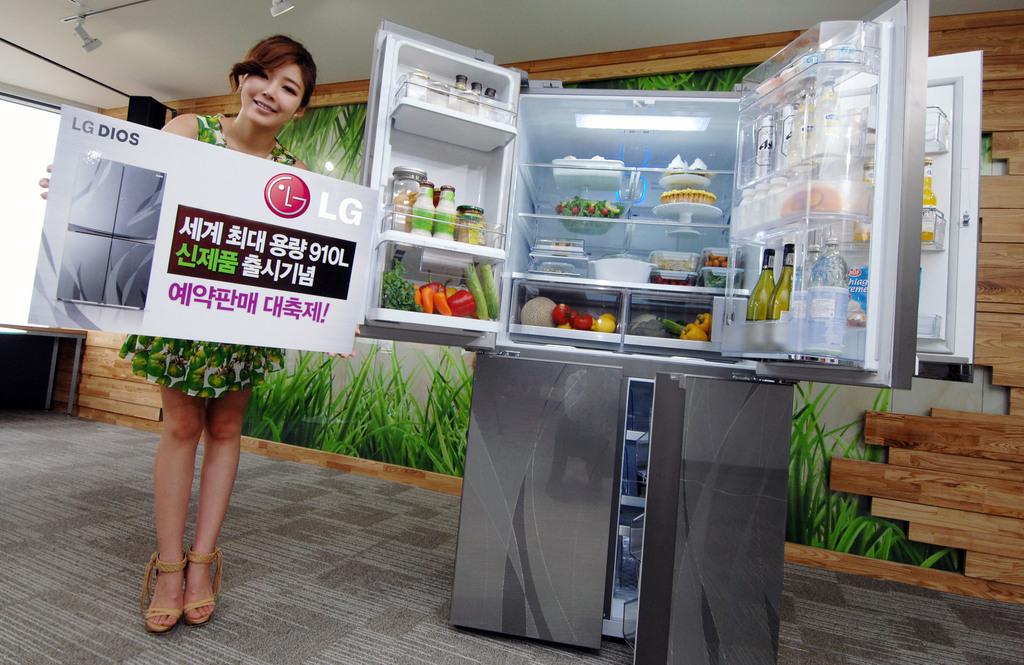What brand of fridge is being advertised?
Your response must be concise. Lg. What kind of lg fridge is this?
Provide a short and direct response. Lg dios. 